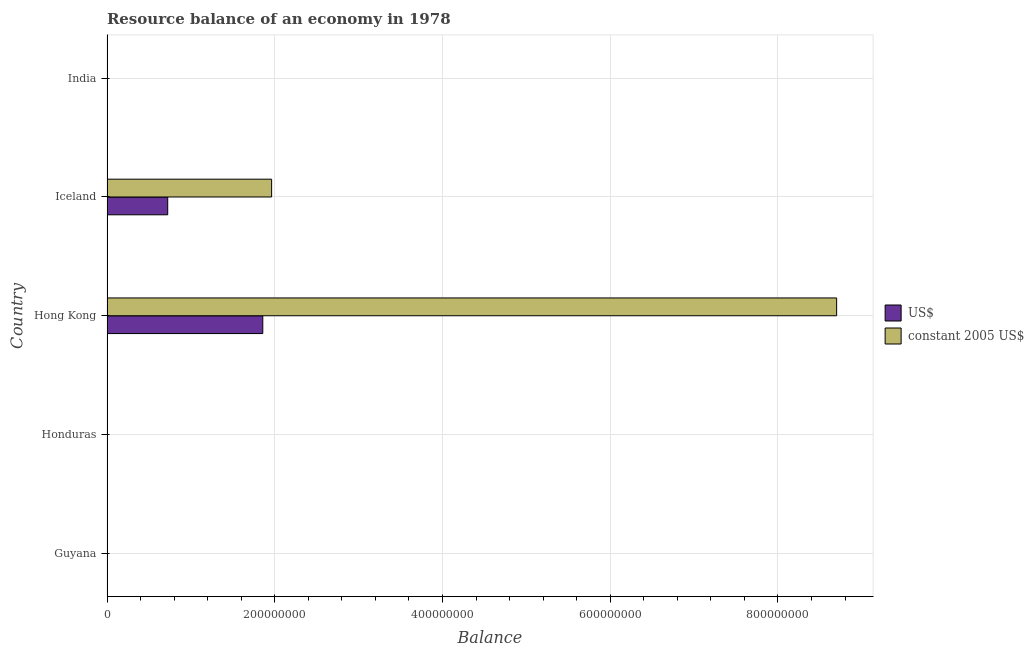Are the number of bars per tick equal to the number of legend labels?
Your response must be concise. No. How many bars are there on the 5th tick from the top?
Offer a terse response. 0. What is the label of the 3rd group of bars from the top?
Your answer should be compact. Hong Kong. What is the resource balance in us$ in Guyana?
Offer a terse response. 0. Across all countries, what is the maximum resource balance in constant us$?
Your answer should be very brief. 8.70e+08. In which country was the resource balance in us$ maximum?
Your answer should be compact. Hong Kong. What is the total resource balance in constant us$ in the graph?
Provide a short and direct response. 1.07e+09. What is the difference between the resource balance in constant us$ in Hong Kong and that in Iceland?
Your response must be concise. 6.74e+08. What is the difference between the resource balance in us$ in Hong Kong and the resource balance in constant us$ in India?
Your answer should be compact. 1.86e+08. What is the average resource balance in constant us$ per country?
Offer a very short reply. 2.13e+08. What is the difference between the resource balance in us$ and resource balance in constant us$ in Iceland?
Provide a succinct answer. -1.24e+08. In how many countries, is the resource balance in constant us$ greater than 440000000 units?
Provide a succinct answer. 1. What is the ratio of the resource balance in constant us$ in Hong Kong to that in Iceland?
Make the answer very short. 4.43. What is the difference between the highest and the lowest resource balance in constant us$?
Provide a succinct answer. 8.70e+08. In how many countries, is the resource balance in constant us$ greater than the average resource balance in constant us$ taken over all countries?
Your answer should be very brief. 1. Are all the bars in the graph horizontal?
Offer a very short reply. Yes. How many countries are there in the graph?
Give a very brief answer. 5. Are the values on the major ticks of X-axis written in scientific E-notation?
Offer a terse response. No. Does the graph contain any zero values?
Give a very brief answer. Yes. Does the graph contain grids?
Your answer should be compact. Yes. How are the legend labels stacked?
Provide a succinct answer. Vertical. What is the title of the graph?
Keep it short and to the point. Resource balance of an economy in 1978. Does "Netherlands" appear as one of the legend labels in the graph?
Provide a succinct answer. No. What is the label or title of the X-axis?
Offer a very short reply. Balance. What is the label or title of the Y-axis?
Offer a very short reply. Country. What is the Balance of US$ in Guyana?
Provide a short and direct response. 0. What is the Balance in US$ in Honduras?
Offer a terse response. 0. What is the Balance in constant 2005 US$ in Honduras?
Offer a terse response. 0. What is the Balance in US$ in Hong Kong?
Provide a succinct answer. 1.86e+08. What is the Balance in constant 2005 US$ in Hong Kong?
Give a very brief answer. 8.70e+08. What is the Balance in US$ in Iceland?
Provide a short and direct response. 7.24e+07. What is the Balance in constant 2005 US$ in Iceland?
Make the answer very short. 1.96e+08. What is the Balance of constant 2005 US$ in India?
Ensure brevity in your answer.  0. Across all countries, what is the maximum Balance in US$?
Make the answer very short. 1.86e+08. Across all countries, what is the maximum Balance in constant 2005 US$?
Your response must be concise. 8.70e+08. Across all countries, what is the minimum Balance in US$?
Your answer should be compact. 0. What is the total Balance in US$ in the graph?
Provide a short and direct response. 2.58e+08. What is the total Balance in constant 2005 US$ in the graph?
Offer a terse response. 1.07e+09. What is the difference between the Balance in US$ in Hong Kong and that in Iceland?
Offer a very short reply. 1.13e+08. What is the difference between the Balance in constant 2005 US$ in Hong Kong and that in Iceland?
Provide a short and direct response. 6.74e+08. What is the difference between the Balance of US$ in Hong Kong and the Balance of constant 2005 US$ in Iceland?
Offer a very short reply. -1.05e+07. What is the average Balance of US$ per country?
Offer a very short reply. 5.16e+07. What is the average Balance in constant 2005 US$ per country?
Offer a very short reply. 2.13e+08. What is the difference between the Balance of US$ and Balance of constant 2005 US$ in Hong Kong?
Your answer should be compact. -6.84e+08. What is the difference between the Balance of US$ and Balance of constant 2005 US$ in Iceland?
Provide a succinct answer. -1.24e+08. What is the ratio of the Balance in US$ in Hong Kong to that in Iceland?
Your answer should be compact. 2.57. What is the ratio of the Balance in constant 2005 US$ in Hong Kong to that in Iceland?
Provide a short and direct response. 4.43. What is the difference between the highest and the lowest Balance of US$?
Your answer should be very brief. 1.86e+08. What is the difference between the highest and the lowest Balance of constant 2005 US$?
Your response must be concise. 8.70e+08. 